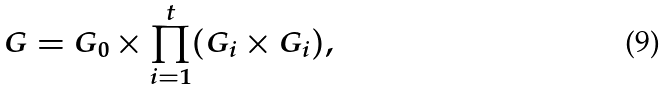Convert formula to latex. <formula><loc_0><loc_0><loc_500><loc_500>G = G _ { 0 } \times \prod _ { i = 1 } ^ { t } ( G _ { i } \times G _ { i } ) ,</formula> 